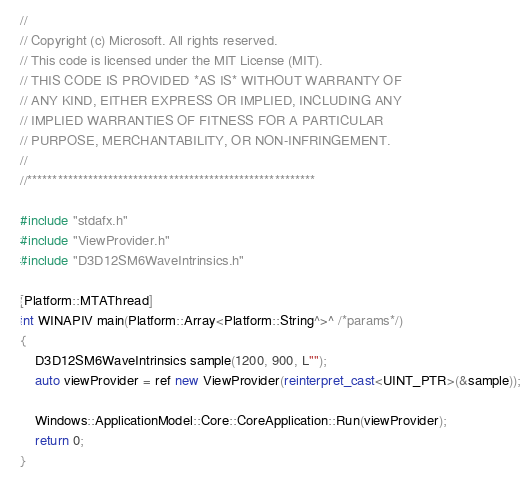Convert code to text. <code><loc_0><loc_0><loc_500><loc_500><_C++_>//
// Copyright (c) Microsoft. All rights reserved.
// This code is licensed under the MIT License (MIT).
// THIS CODE IS PROVIDED *AS IS* WITHOUT WARRANTY OF
// ANY KIND, EITHER EXPRESS OR IMPLIED, INCLUDING ANY
// IMPLIED WARRANTIES OF FITNESS FOR A PARTICULAR
// PURPOSE, MERCHANTABILITY, OR NON-INFRINGEMENT.
//
//*********************************************************

#include "stdafx.h"
#include "ViewProvider.h"
#include "D3D12SM6WaveIntrinsics.h"

[Platform::MTAThread]
int WINAPIV main(Platform::Array<Platform::String^>^ /*params*/)
{
    D3D12SM6WaveIntrinsics sample(1200, 900, L"");
    auto viewProvider = ref new ViewProvider(reinterpret_cast<UINT_PTR>(&sample));

    Windows::ApplicationModel::Core::CoreApplication::Run(viewProvider);
    return 0;
}
</code> 